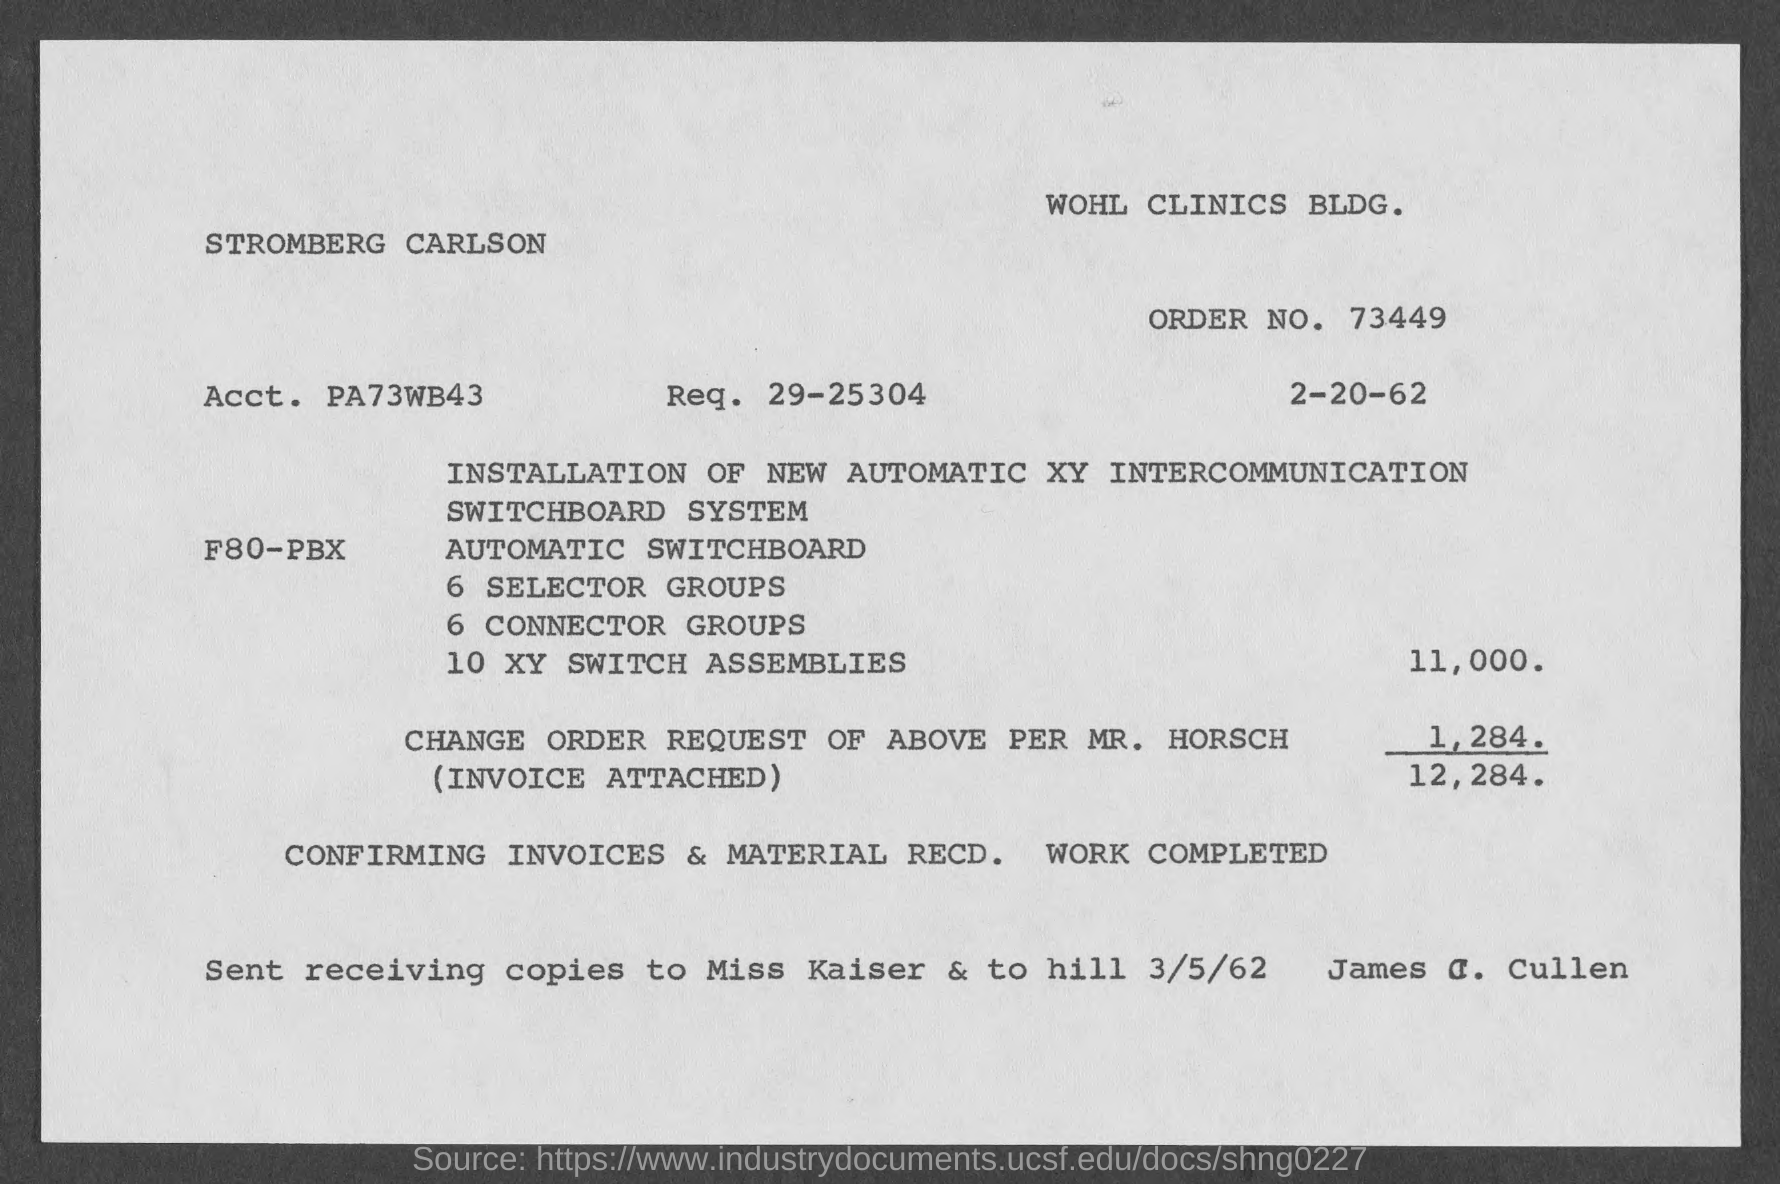What is the order no.?
Ensure brevity in your answer.  73449. What is the date of invoice?
Your response must be concise. 2-20-62. What is the name of the building?
Provide a succinct answer. Wohl Clinics Bldg. What was the invoice about?
Ensure brevity in your answer.  Installation of new automatic XY Intercommunication switchboard system. 